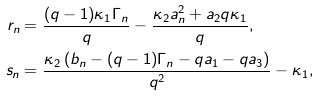<formula> <loc_0><loc_0><loc_500><loc_500>r _ { n } & = \frac { ( q - 1 ) \kappa _ { 1 } \Gamma _ { n } } { q } - \frac { \kappa _ { 2 } a _ { n } ^ { 2 } + a _ { 2 } q \kappa _ { 1 } } { q } , \\ s _ { n } & = \frac { \kappa _ { 2 } \left ( b _ { n } - ( q - 1 ) \Gamma _ { n } - q a _ { 1 } - q a _ { 3 } \right ) } { q ^ { 2 } } - \kappa _ { 1 } ,</formula> 